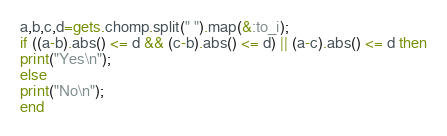Convert code to text. <code><loc_0><loc_0><loc_500><loc_500><_Ruby_>a,b,c,d=gets.chomp.split(" ").map(&:to_i);
if ((a-b).abs() <= d && (c-b).abs() <= d) || (a-c).abs() <= d then
print("Yes\n");
else
print("No\n");
end</code> 